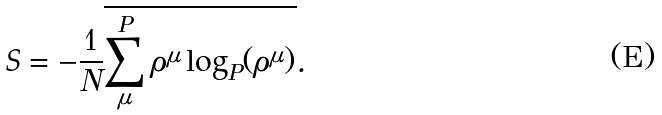<formula> <loc_0><loc_0><loc_500><loc_500>S = - \frac { 1 } { N } \overline { \sum _ { \mu } ^ { P } \rho ^ { \mu } \log _ { P } ( \rho ^ { \mu } ) } .</formula> 